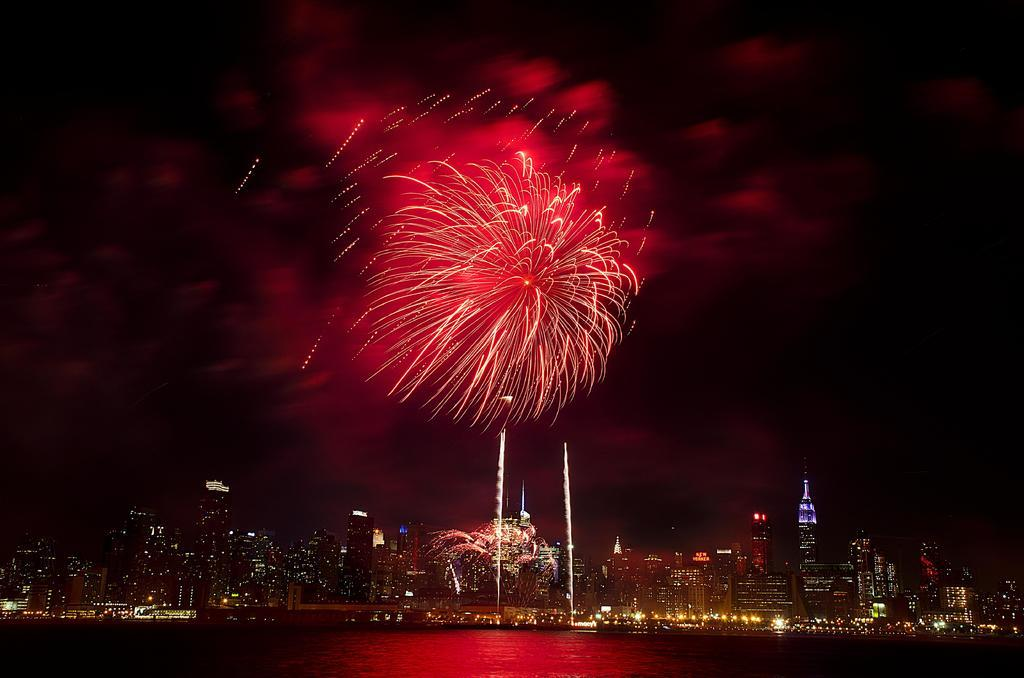What is the lighting condition in the image? The image is taken in the dark. What can be seen at the bottom of the image? There is water visible at the bottom of the image. What is present at the top of the image? Fireworks are present at the top of the image. What type of structures can be seen in the background of the image? There are buildings in the background of the image. What else is visible in the background of the image? Lights and the sky are visible in the background of the image. What type of dirt can be seen on the table in the image? There is no table or dirt present in the image. How many islands are visible in the image? There are no islands visible in the image. 